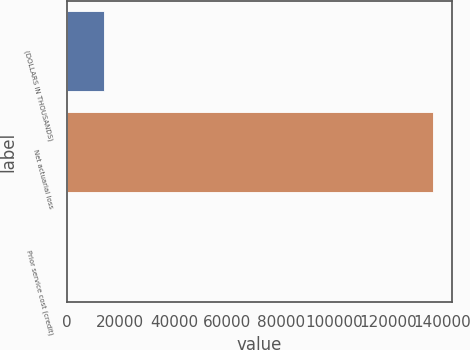<chart> <loc_0><loc_0><loc_500><loc_500><bar_chart><fcel>(DOLLARS IN THOUSANDS)<fcel>Net actuarial loss<fcel>Prior service cost (credit)<nl><fcel>13863.4<fcel>136888<fcel>194<nl></chart> 